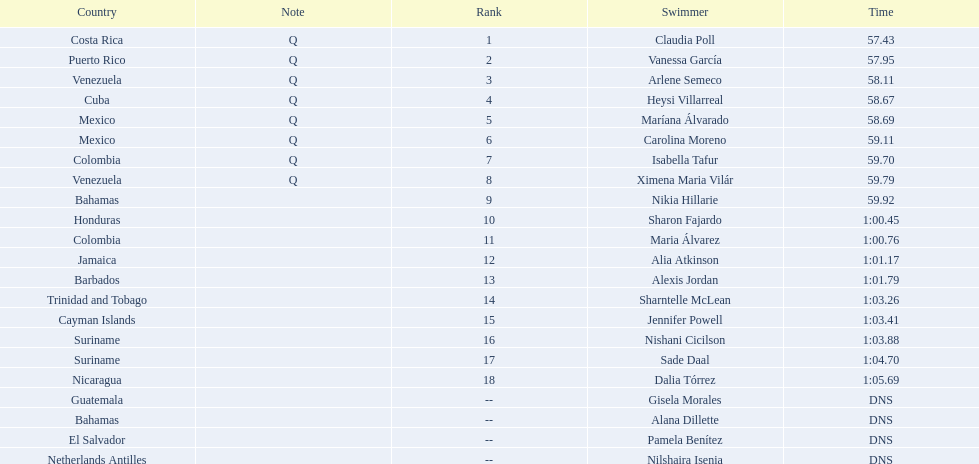How many swimmers are from mexico? 2. 